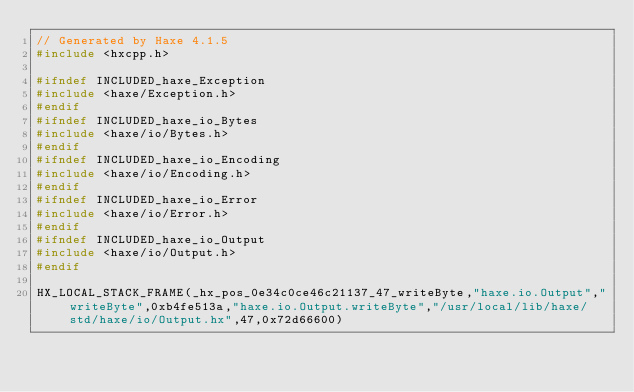<code> <loc_0><loc_0><loc_500><loc_500><_C++_>// Generated by Haxe 4.1.5
#include <hxcpp.h>

#ifndef INCLUDED_haxe_Exception
#include <haxe/Exception.h>
#endif
#ifndef INCLUDED_haxe_io_Bytes
#include <haxe/io/Bytes.h>
#endif
#ifndef INCLUDED_haxe_io_Encoding
#include <haxe/io/Encoding.h>
#endif
#ifndef INCLUDED_haxe_io_Error
#include <haxe/io/Error.h>
#endif
#ifndef INCLUDED_haxe_io_Output
#include <haxe/io/Output.h>
#endif

HX_LOCAL_STACK_FRAME(_hx_pos_0e34c0ce46c21137_47_writeByte,"haxe.io.Output","writeByte",0xb4fe513a,"haxe.io.Output.writeByte","/usr/local/lib/haxe/std/haxe/io/Output.hx",47,0x72d66600)</code> 